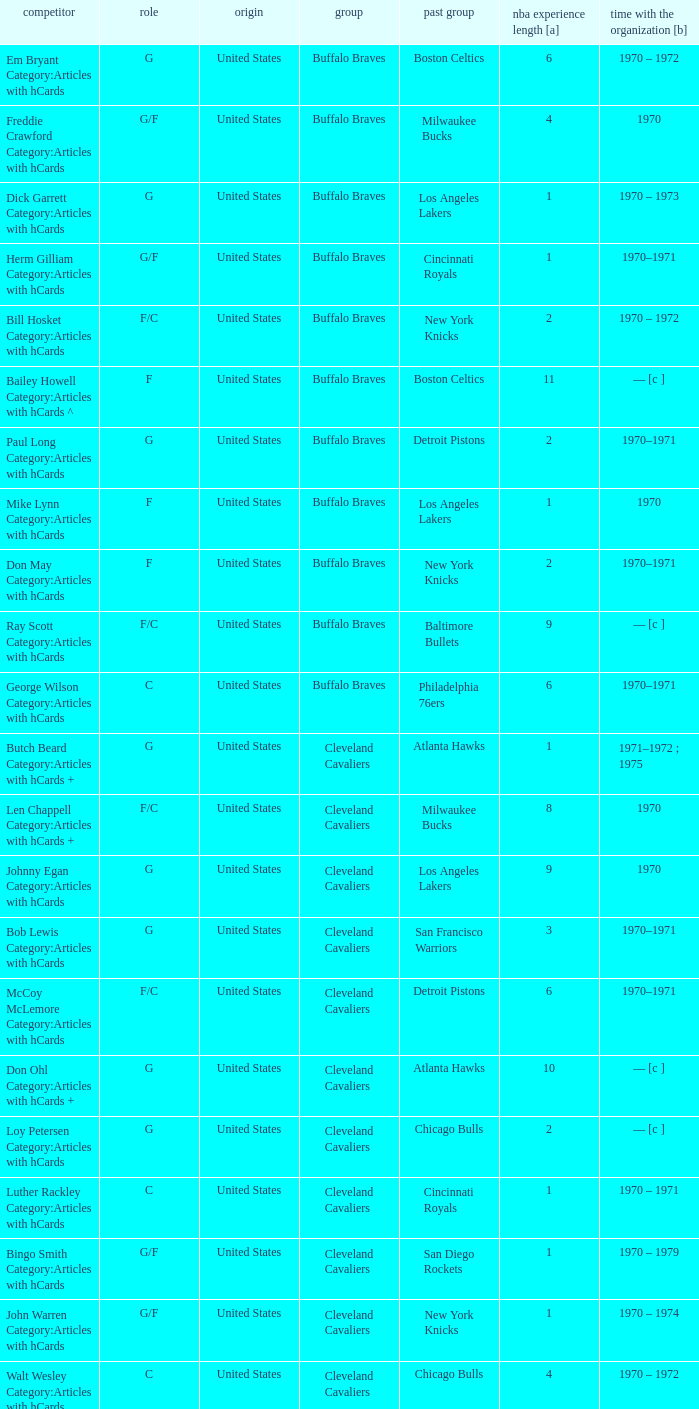Who is the player from the Buffalo Braves with the previous team Los Angeles Lakers and a career with the franchase in 1970? Mike Lynn Category:Articles with hCards. 